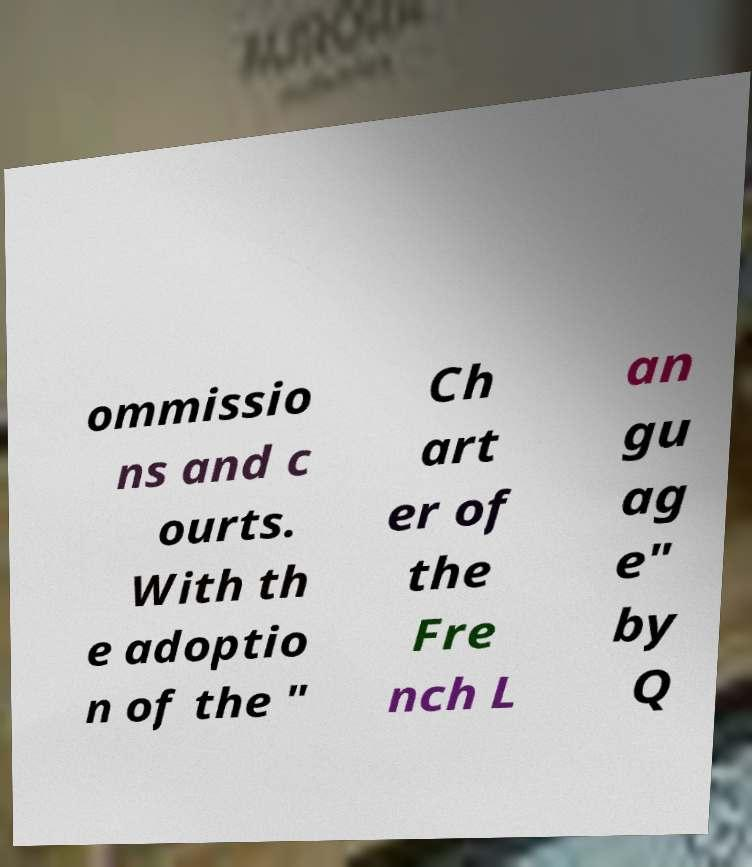Could you assist in decoding the text presented in this image and type it out clearly? ommissio ns and c ourts. With th e adoptio n of the " Ch art er of the Fre nch L an gu ag e" by Q 